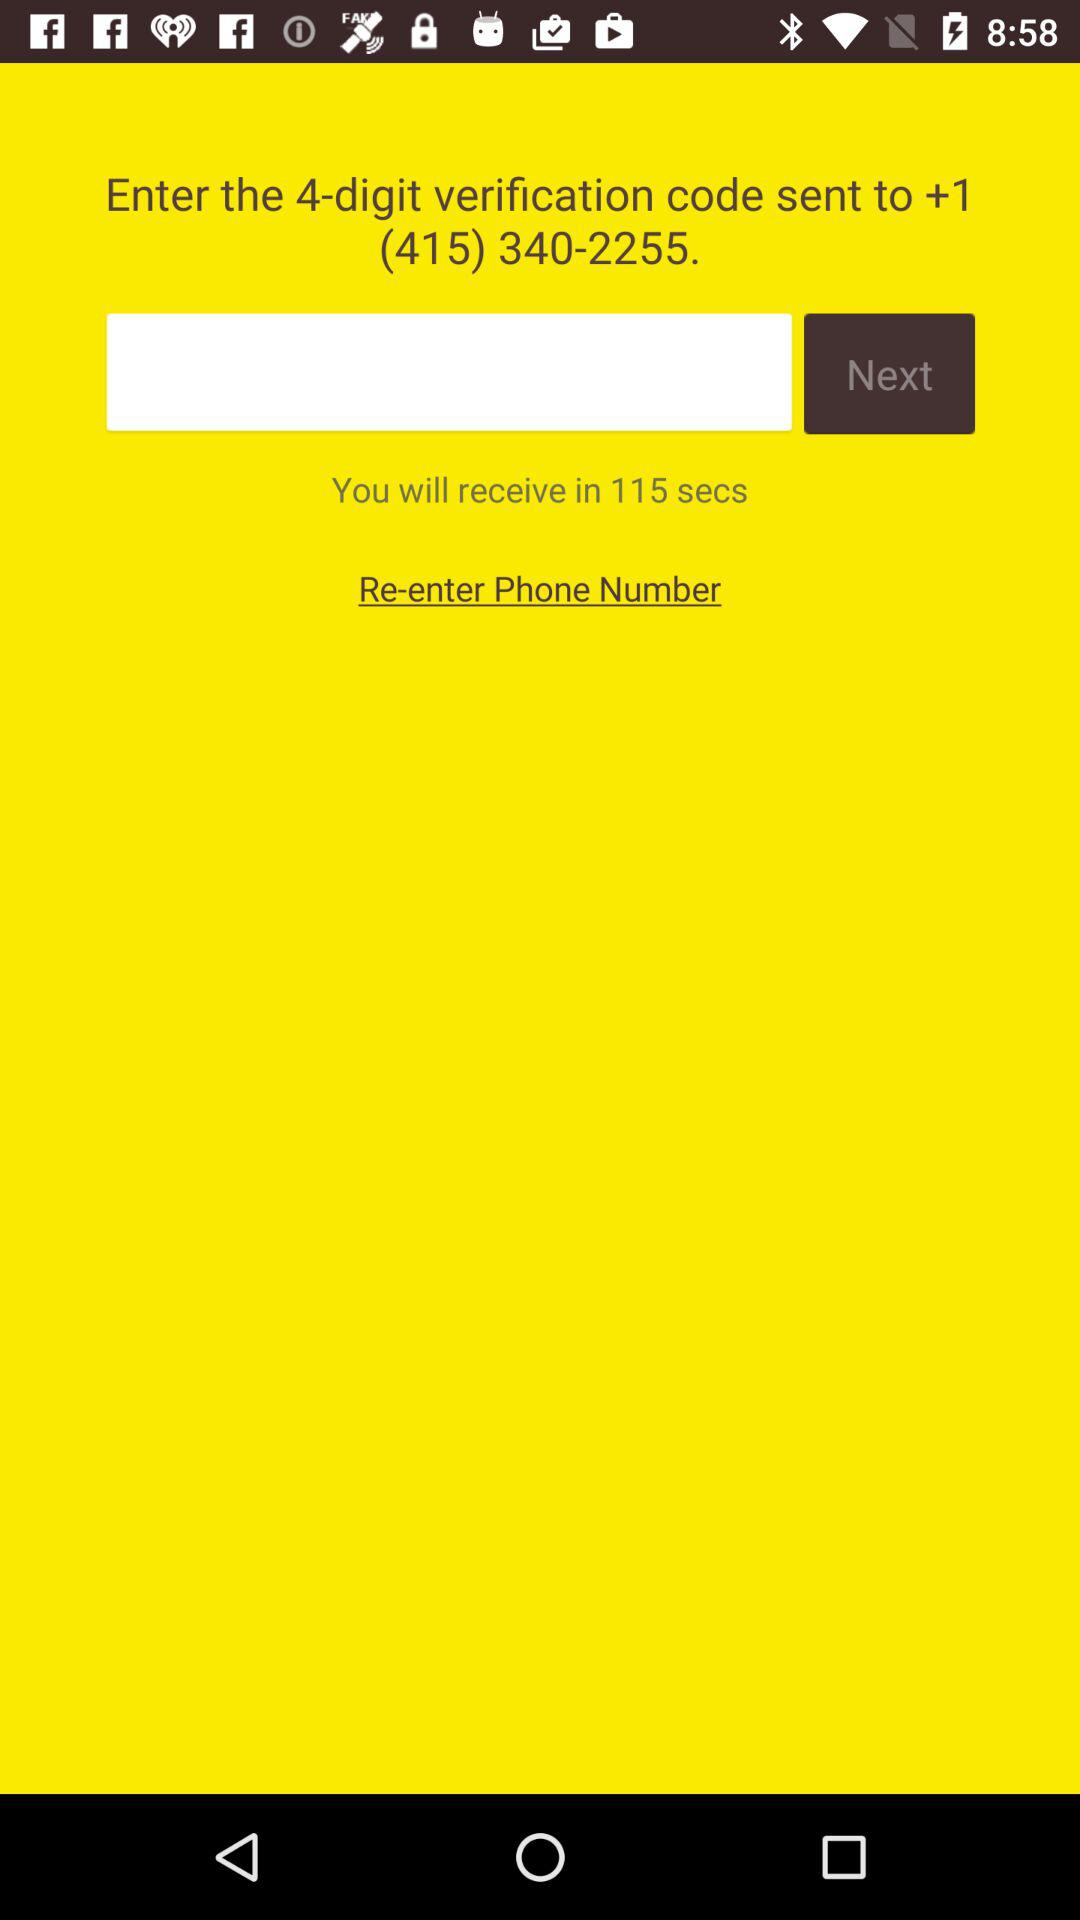Which tab is selected?
When the provided information is insufficient, respond with <no answer>. <no answer> 